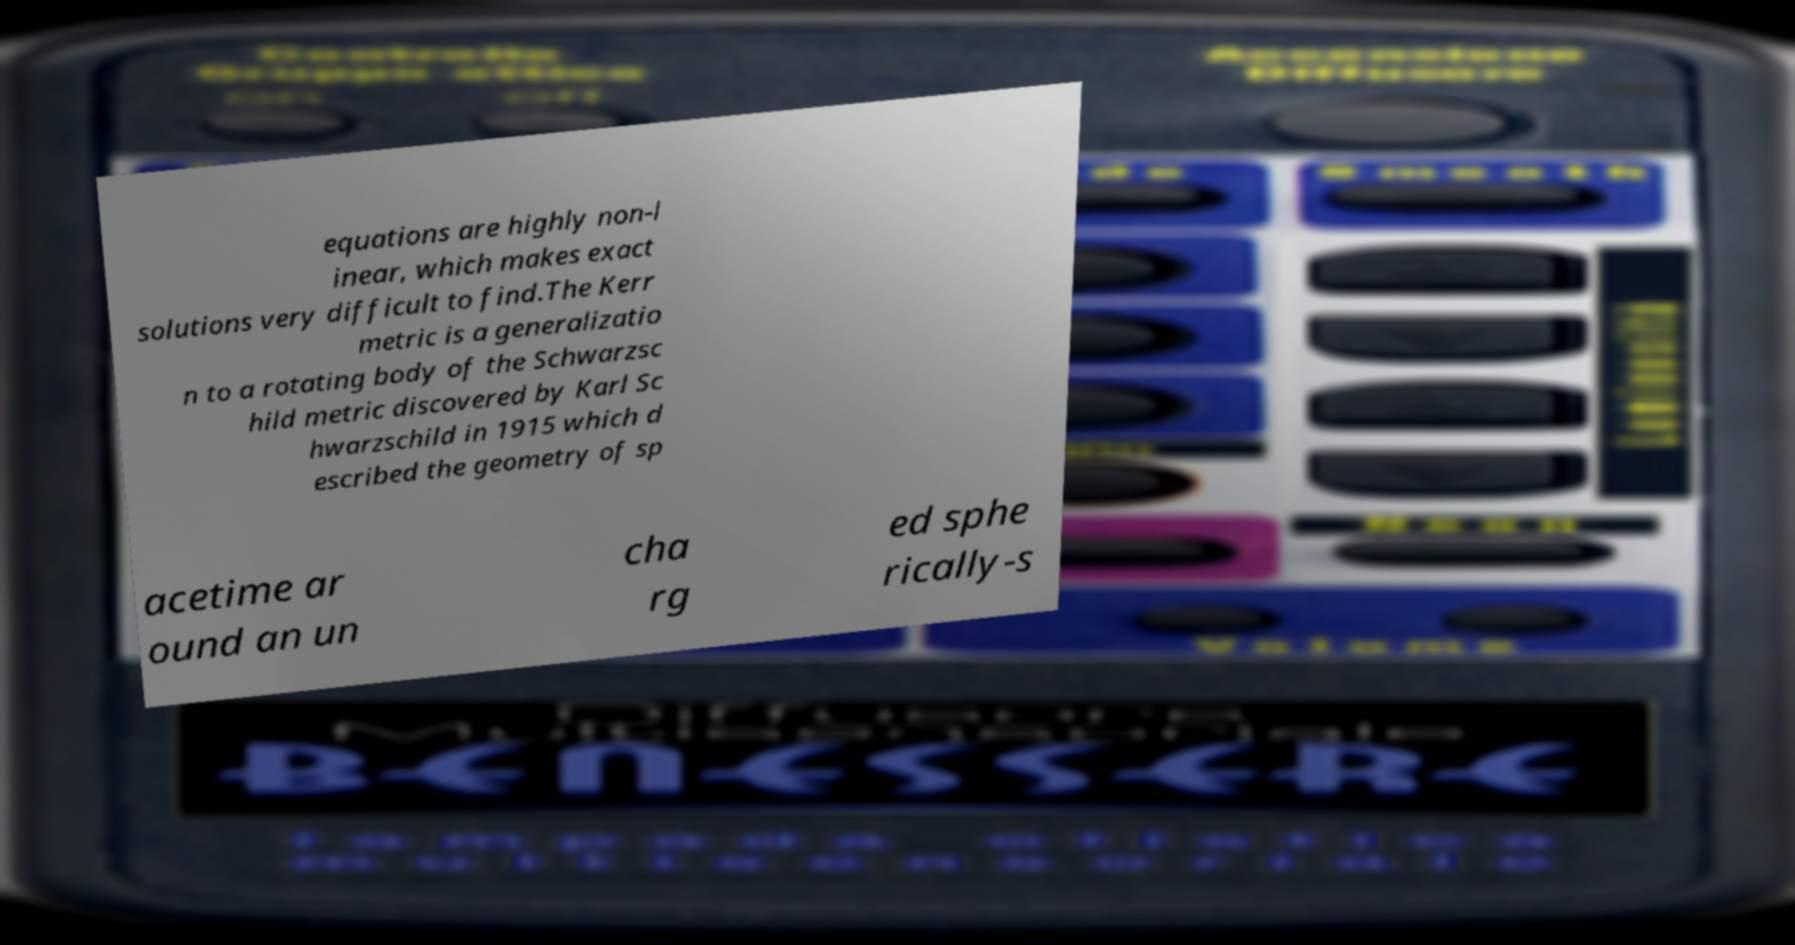Could you extract and type out the text from this image? equations are highly non-l inear, which makes exact solutions very difficult to find.The Kerr metric is a generalizatio n to a rotating body of the Schwarzsc hild metric discovered by Karl Sc hwarzschild in 1915 which d escribed the geometry of sp acetime ar ound an un cha rg ed sphe rically-s 